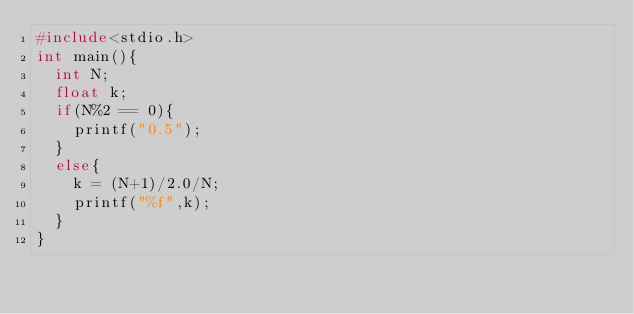Convert code to text. <code><loc_0><loc_0><loc_500><loc_500><_C_>#include<stdio.h>
int main(){
  int N;
  float k;
  if(N%2 == 0){
    printf("0.5");
  }
  else{
    k = (N+1)/2.0/N;
    printf("%f",k);
  }
}</code> 